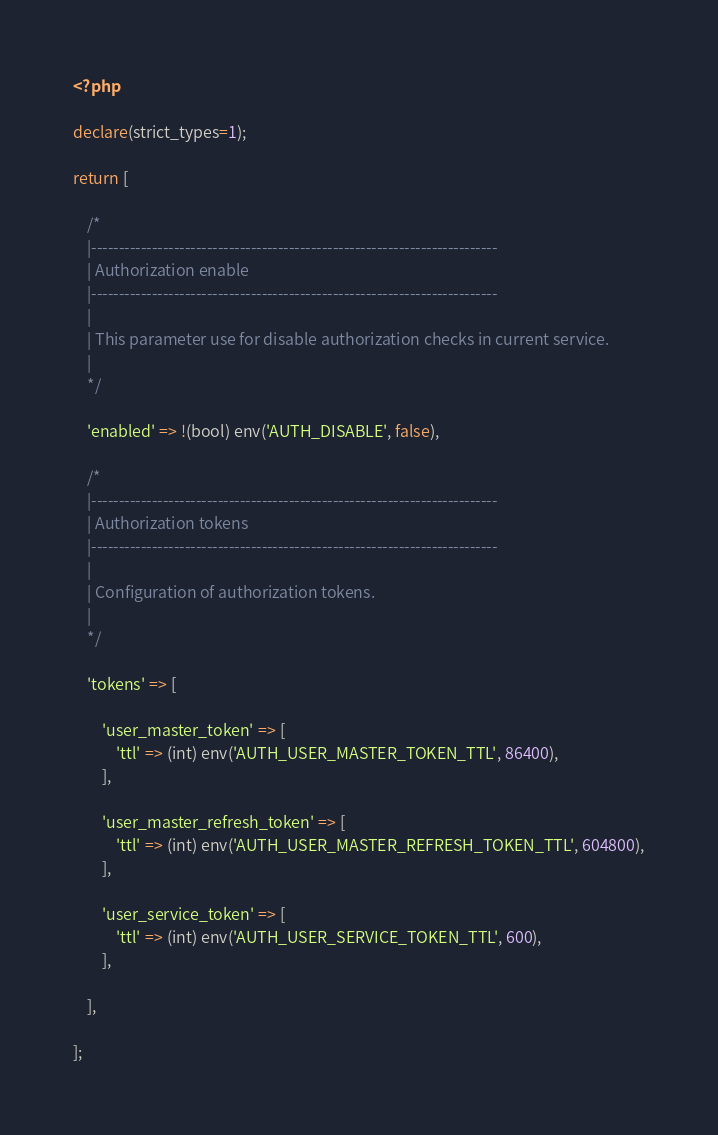<code> <loc_0><loc_0><loc_500><loc_500><_PHP_><?php

declare(strict_types=1);

return [

    /*
    |--------------------------------------------------------------------------
    | Authorization enable
    |--------------------------------------------------------------------------
    |
    | This parameter use for disable authorization checks in current service.
    |
    */

    'enabled' => !(bool) env('AUTH_DISABLE', false),

    /*
    |--------------------------------------------------------------------------
    | Authorization tokens
    |--------------------------------------------------------------------------
    |
    | Configuration of authorization tokens.
    |
    */

    'tokens' => [

        'user_master_token' => [
            'ttl' => (int) env('AUTH_USER_MASTER_TOKEN_TTL', 86400),
        ],

        'user_master_refresh_token' => [
            'ttl' => (int) env('AUTH_USER_MASTER_REFRESH_TOKEN_TTL', 604800),
        ],

        'user_service_token' => [
            'ttl' => (int) env('AUTH_USER_SERVICE_TOKEN_TTL', 600),
        ],

    ],

];
</code> 